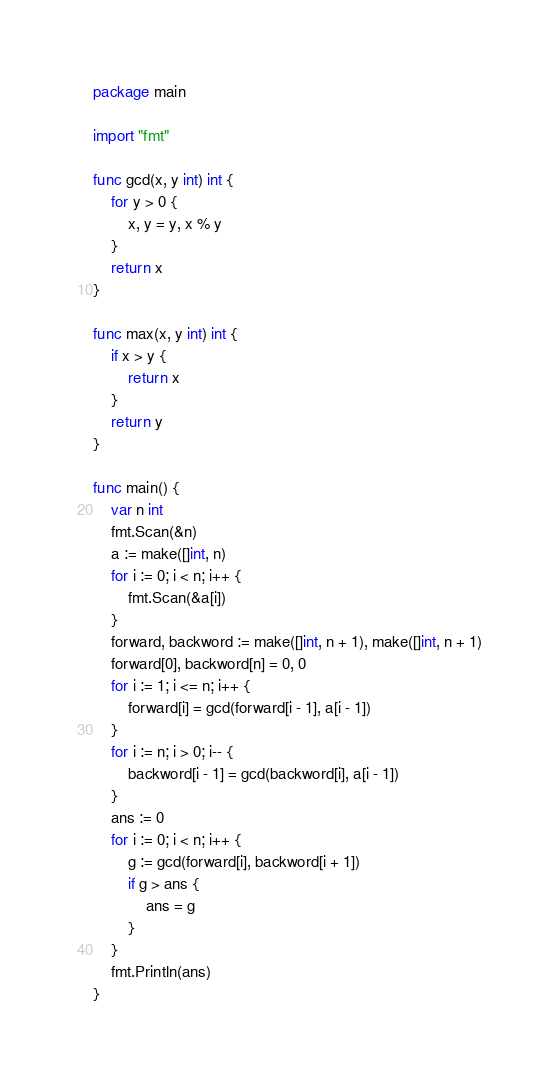<code> <loc_0><loc_0><loc_500><loc_500><_Go_>package main

import "fmt"

func gcd(x, y int) int {
    for y > 0 {
        x, y = y, x % y
    }
    return x
}

func max(x, y int) int {
    if x > y {
        return x
    }
    return y
}

func main() {
    var n int
    fmt.Scan(&n)
    a := make([]int, n)
    for i := 0; i < n; i++ {
        fmt.Scan(&a[i])
    }
    forward, backword := make([]int, n + 1), make([]int, n + 1)
    forward[0], backword[n] = 0, 0
    for i := 1; i <= n; i++ {
        forward[i] = gcd(forward[i - 1], a[i - 1])
    }
    for i := n; i > 0; i-- {
        backword[i - 1] = gcd(backword[i], a[i - 1])
    }
    ans := 0
    for i := 0; i < n; i++ {
        g := gcd(forward[i], backword[i + 1])
        if g > ans {
            ans = g
        }
    }
    fmt.Println(ans)
}

</code> 